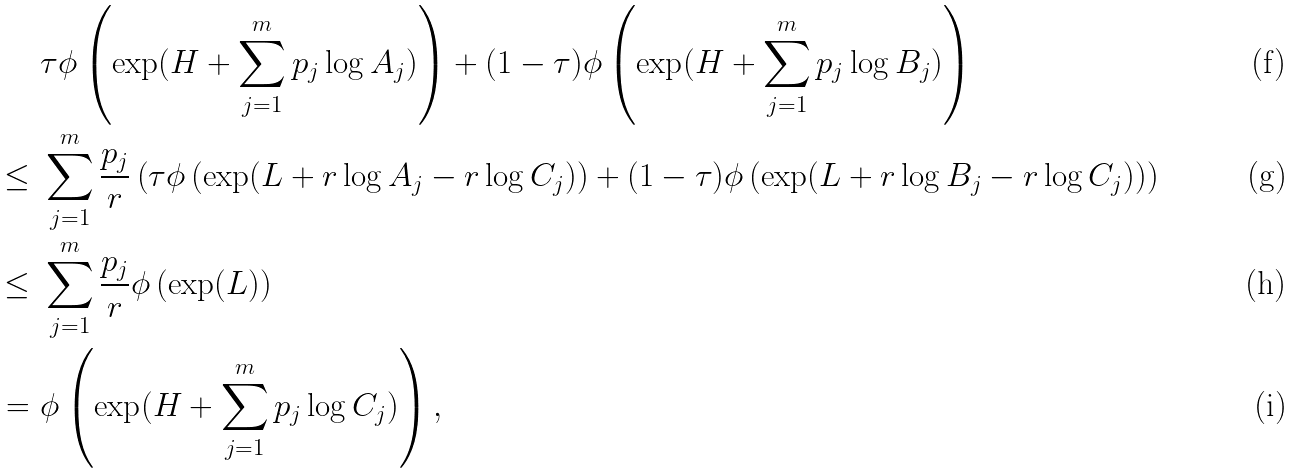Convert formula to latex. <formula><loc_0><loc_0><loc_500><loc_500>& \ \tau \phi \left ( \exp ( H + \sum _ { j = 1 } ^ { m } p _ { j } \log A _ { j } ) \right ) + ( 1 - \tau ) \phi \left ( \exp ( H + \sum _ { j = 1 } ^ { m } p _ { j } \log B _ { j } ) \right ) \\ \leq & \ \sum _ { j = 1 } ^ { m } \frac { p _ { j } } { r } \left ( \tau \phi \left ( \exp ( L + r \log A _ { j } - r \log C _ { j } ) \right ) + ( 1 - \tau ) \phi \left ( \exp ( L + r \log B _ { j } - r \log C _ { j } ) \right ) \right ) \\ \leq & \ \sum _ { j = 1 } ^ { m } \frac { p _ { j } } { r } \phi \left ( \exp ( L ) \right ) \\ = & \ \phi \left ( \exp ( H + \sum _ { j = 1 } ^ { m } p _ { j } \log C _ { j } ) \right ) ,</formula> 